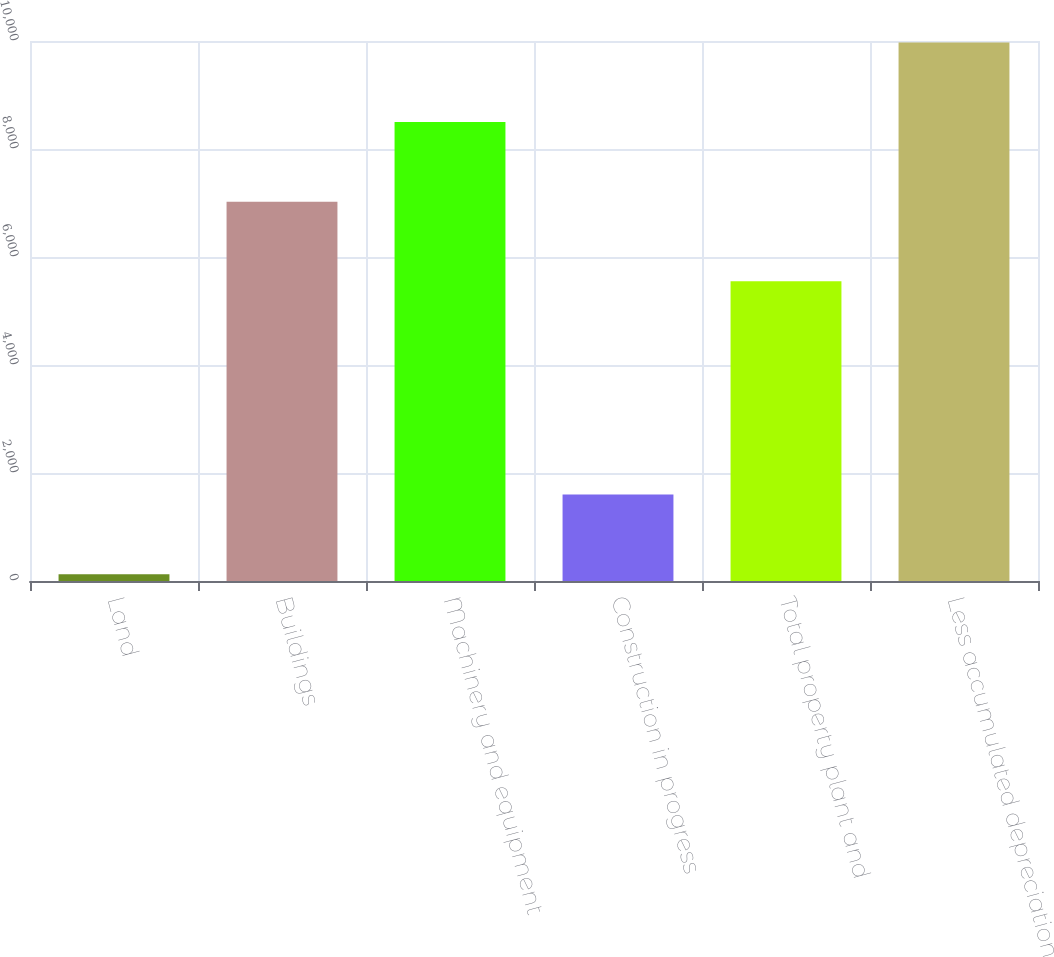Convert chart. <chart><loc_0><loc_0><loc_500><loc_500><bar_chart><fcel>Land<fcel>Buildings<fcel>Machinery and equipment<fcel>Construction in progress<fcel>Total property plant and<fcel>Less accumulated depreciation<nl><fcel>127<fcel>7024<fcel>8499<fcel>1602<fcel>5549<fcel>9974<nl></chart> 